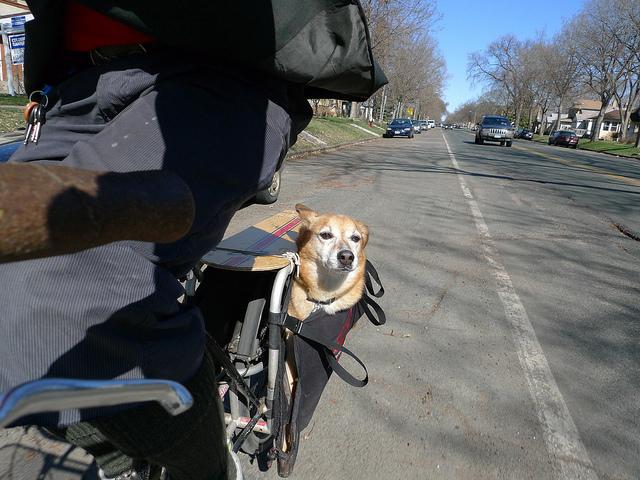How many ears are visible?
Write a very short answer. 1. Is this dog in a car?
Answer briefly. No. Does the dog look comfortable?
Quick response, please. Yes. 